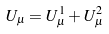Convert formula to latex. <formula><loc_0><loc_0><loc_500><loc_500>U _ { \mu } = U _ { \mu } ^ { 1 } + U _ { \mu } ^ { 2 }</formula> 